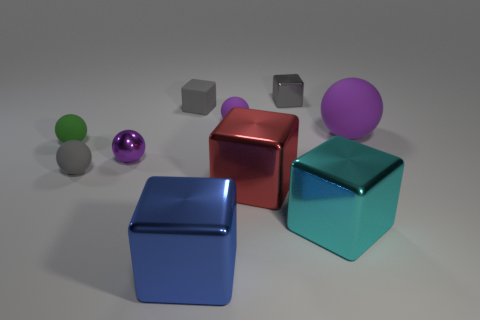What number of things are large shiny blocks right of the large blue shiny object or matte balls?
Give a very brief answer. 6. Are there any purple rubber spheres behind the purple shiny object to the right of the tiny matte ball that is on the left side of the small gray sphere?
Your response must be concise. Yes. How many purple matte things are there?
Your response must be concise. 2. How many objects are either tiny cubes that are behind the cyan shiny cube or metal things behind the blue metallic block?
Give a very brief answer. 5. There is a gray rubber object that is to the left of the purple metallic sphere; is it the same size as the red metal object?
Your answer should be compact. No. There is a blue shiny object that is the same shape as the small gray metal object; what is its size?
Make the answer very short. Large. What material is the gray ball that is the same size as the green rubber thing?
Your response must be concise. Rubber. There is a red object that is the same shape as the large cyan thing; what is it made of?
Make the answer very short. Metal. What number of other objects are there of the same size as the cyan object?
Offer a very short reply. 3. What size is the other block that is the same color as the rubber block?
Offer a terse response. Small. 